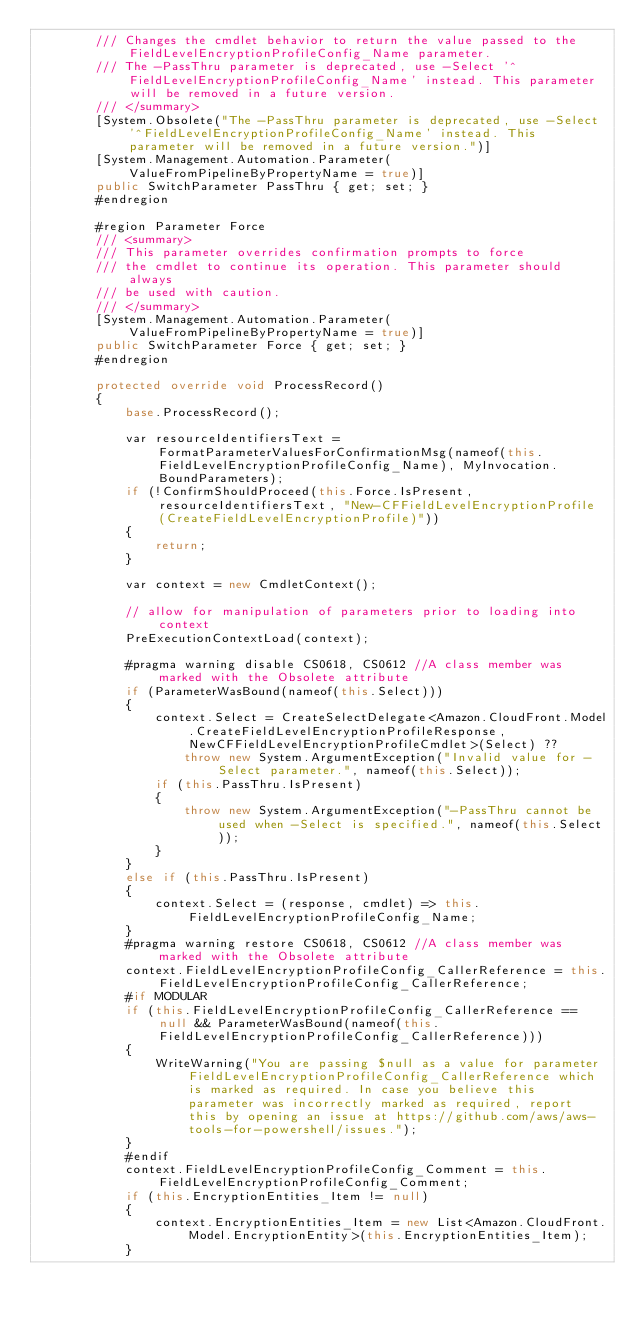<code> <loc_0><loc_0><loc_500><loc_500><_C#_>        /// Changes the cmdlet behavior to return the value passed to the FieldLevelEncryptionProfileConfig_Name parameter.
        /// The -PassThru parameter is deprecated, use -Select '^FieldLevelEncryptionProfileConfig_Name' instead. This parameter will be removed in a future version.
        /// </summary>
        [System.Obsolete("The -PassThru parameter is deprecated, use -Select '^FieldLevelEncryptionProfileConfig_Name' instead. This parameter will be removed in a future version.")]
        [System.Management.Automation.Parameter(ValueFromPipelineByPropertyName = true)]
        public SwitchParameter PassThru { get; set; }
        #endregion
        
        #region Parameter Force
        /// <summary>
        /// This parameter overrides confirmation prompts to force 
        /// the cmdlet to continue its operation. This parameter should always
        /// be used with caution.
        /// </summary>
        [System.Management.Automation.Parameter(ValueFromPipelineByPropertyName = true)]
        public SwitchParameter Force { get; set; }
        #endregion
        
        protected override void ProcessRecord()
        {
            base.ProcessRecord();
            
            var resourceIdentifiersText = FormatParameterValuesForConfirmationMsg(nameof(this.FieldLevelEncryptionProfileConfig_Name), MyInvocation.BoundParameters);
            if (!ConfirmShouldProceed(this.Force.IsPresent, resourceIdentifiersText, "New-CFFieldLevelEncryptionProfile (CreateFieldLevelEncryptionProfile)"))
            {
                return;
            }
            
            var context = new CmdletContext();
            
            // allow for manipulation of parameters prior to loading into context
            PreExecutionContextLoad(context);
            
            #pragma warning disable CS0618, CS0612 //A class member was marked with the Obsolete attribute
            if (ParameterWasBound(nameof(this.Select)))
            {
                context.Select = CreateSelectDelegate<Amazon.CloudFront.Model.CreateFieldLevelEncryptionProfileResponse, NewCFFieldLevelEncryptionProfileCmdlet>(Select) ??
                    throw new System.ArgumentException("Invalid value for -Select parameter.", nameof(this.Select));
                if (this.PassThru.IsPresent)
                {
                    throw new System.ArgumentException("-PassThru cannot be used when -Select is specified.", nameof(this.Select));
                }
            }
            else if (this.PassThru.IsPresent)
            {
                context.Select = (response, cmdlet) => this.FieldLevelEncryptionProfileConfig_Name;
            }
            #pragma warning restore CS0618, CS0612 //A class member was marked with the Obsolete attribute
            context.FieldLevelEncryptionProfileConfig_CallerReference = this.FieldLevelEncryptionProfileConfig_CallerReference;
            #if MODULAR
            if (this.FieldLevelEncryptionProfileConfig_CallerReference == null && ParameterWasBound(nameof(this.FieldLevelEncryptionProfileConfig_CallerReference)))
            {
                WriteWarning("You are passing $null as a value for parameter FieldLevelEncryptionProfileConfig_CallerReference which is marked as required. In case you believe this parameter was incorrectly marked as required, report this by opening an issue at https://github.com/aws/aws-tools-for-powershell/issues.");
            }
            #endif
            context.FieldLevelEncryptionProfileConfig_Comment = this.FieldLevelEncryptionProfileConfig_Comment;
            if (this.EncryptionEntities_Item != null)
            {
                context.EncryptionEntities_Item = new List<Amazon.CloudFront.Model.EncryptionEntity>(this.EncryptionEntities_Item);
            }</code> 